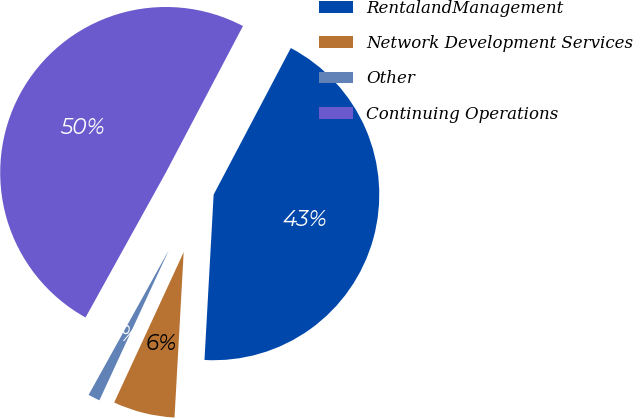Convert chart to OTSL. <chart><loc_0><loc_0><loc_500><loc_500><pie_chart><fcel>RentalandManagement<fcel>Network Development Services<fcel>Other<fcel>Continuing Operations<nl><fcel>43.17%<fcel>6.01%<fcel>1.16%<fcel>49.66%<nl></chart> 